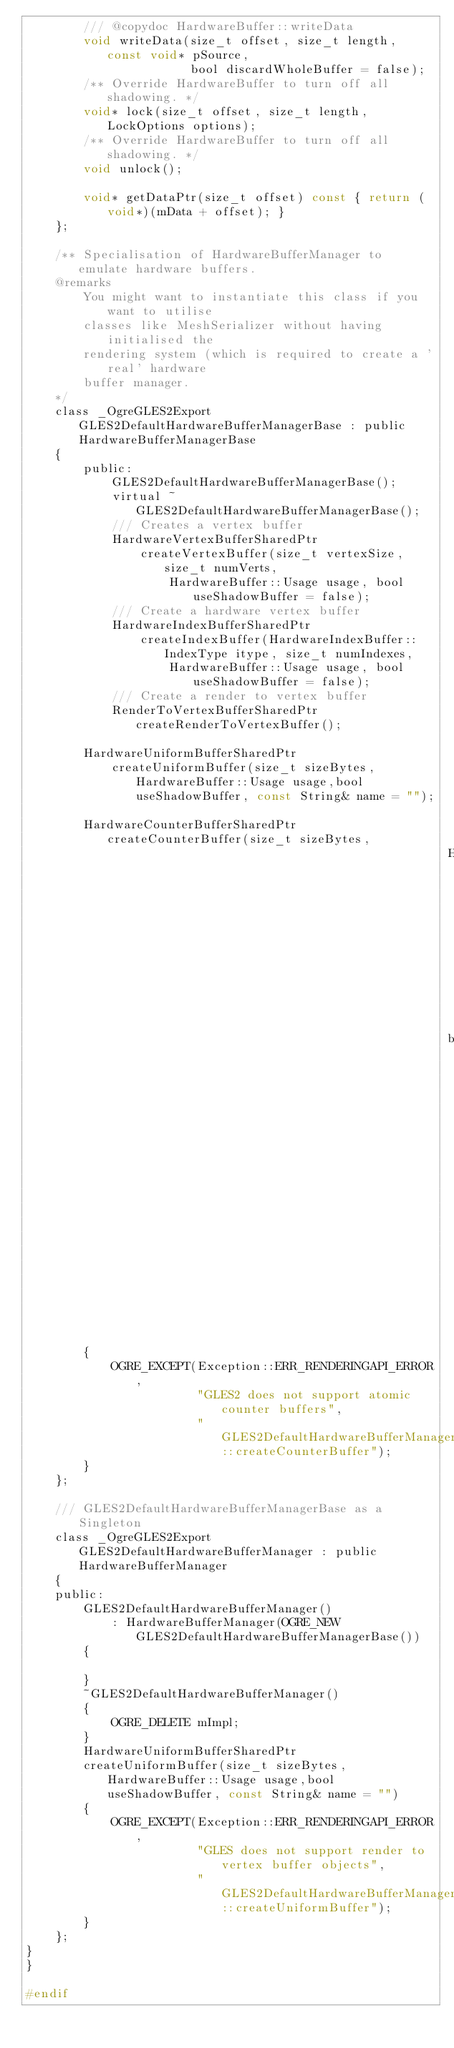<code> <loc_0><loc_0><loc_500><loc_500><_C_>        /// @copydoc HardwareBuffer::writeData
        void writeData(size_t offset, size_t length, const void* pSource,
                       bool discardWholeBuffer = false);
        /** Override HardwareBuffer to turn off all shadowing. */
        void* lock(size_t offset, size_t length, LockOptions options);
        /** Override HardwareBuffer to turn off all shadowing. */
        void unlock();

        void* getDataPtr(size_t offset) const { return (void*)(mData + offset); }
    };

    /** Specialisation of HardwareBufferManager to emulate hardware buffers.
    @remarks
        You might want to instantiate this class if you want to utilise
        classes like MeshSerializer without having initialised the 
        rendering system (which is required to create a 'real' hardware
        buffer manager.
    */
    class _OgreGLES2Export GLES2DefaultHardwareBufferManagerBase : public HardwareBufferManagerBase
    {
        public:
            GLES2DefaultHardwareBufferManagerBase();
            virtual ~GLES2DefaultHardwareBufferManagerBase();
            /// Creates a vertex buffer
            HardwareVertexBufferSharedPtr
                createVertexBuffer(size_t vertexSize, size_t numVerts,
                    HardwareBuffer::Usage usage, bool useShadowBuffer = false);
            /// Create a hardware vertex buffer
            HardwareIndexBufferSharedPtr
                createIndexBuffer(HardwareIndexBuffer::IndexType itype, size_t numIndexes,
                    HardwareBuffer::Usage usage, bool useShadowBuffer = false);
            /// Create a render to vertex buffer
            RenderToVertexBufferSharedPtr createRenderToVertexBuffer();

        HardwareUniformBufferSharedPtr
            createUniformBuffer(size_t sizeBytes, HardwareBuffer::Usage usage,bool useShadowBuffer, const String& name = "");

        HardwareCounterBufferSharedPtr createCounterBuffer(size_t sizeBytes,
                                                           HardwareBuffer::Usage usage = HardwareBuffer::HBU_DYNAMIC_WRITE_ONLY_DISCARDABLE,
                                                           bool useShadowBuffer = false, const String& name = "")
        {
            OGRE_EXCEPT(Exception::ERR_RENDERINGAPI_ERROR,
                        "GLES2 does not support atomic counter buffers",
                        "GLES2DefaultHardwareBufferManagerBase::createCounterBuffer");
        }
    };

    /// GLES2DefaultHardwareBufferManagerBase as a Singleton
    class _OgreGLES2Export GLES2DefaultHardwareBufferManager : public HardwareBufferManager
    {
    public:
        GLES2DefaultHardwareBufferManager()
            : HardwareBufferManager(OGRE_NEW GLES2DefaultHardwareBufferManagerBase()) 
        {

        }
        ~GLES2DefaultHardwareBufferManager()
        {
            OGRE_DELETE mImpl;
        }
        HardwareUniformBufferSharedPtr
        createUniformBuffer(size_t sizeBytes, HardwareBuffer::Usage usage,bool useShadowBuffer, const String& name = "")
        {
            OGRE_EXCEPT(Exception::ERR_RENDERINGAPI_ERROR,
                        "GLES does not support render to vertex buffer objects",
                        "GLES2DefaultHardwareBufferManager::createUniformBuffer");
        }
    };
}
}

#endif
</code> 